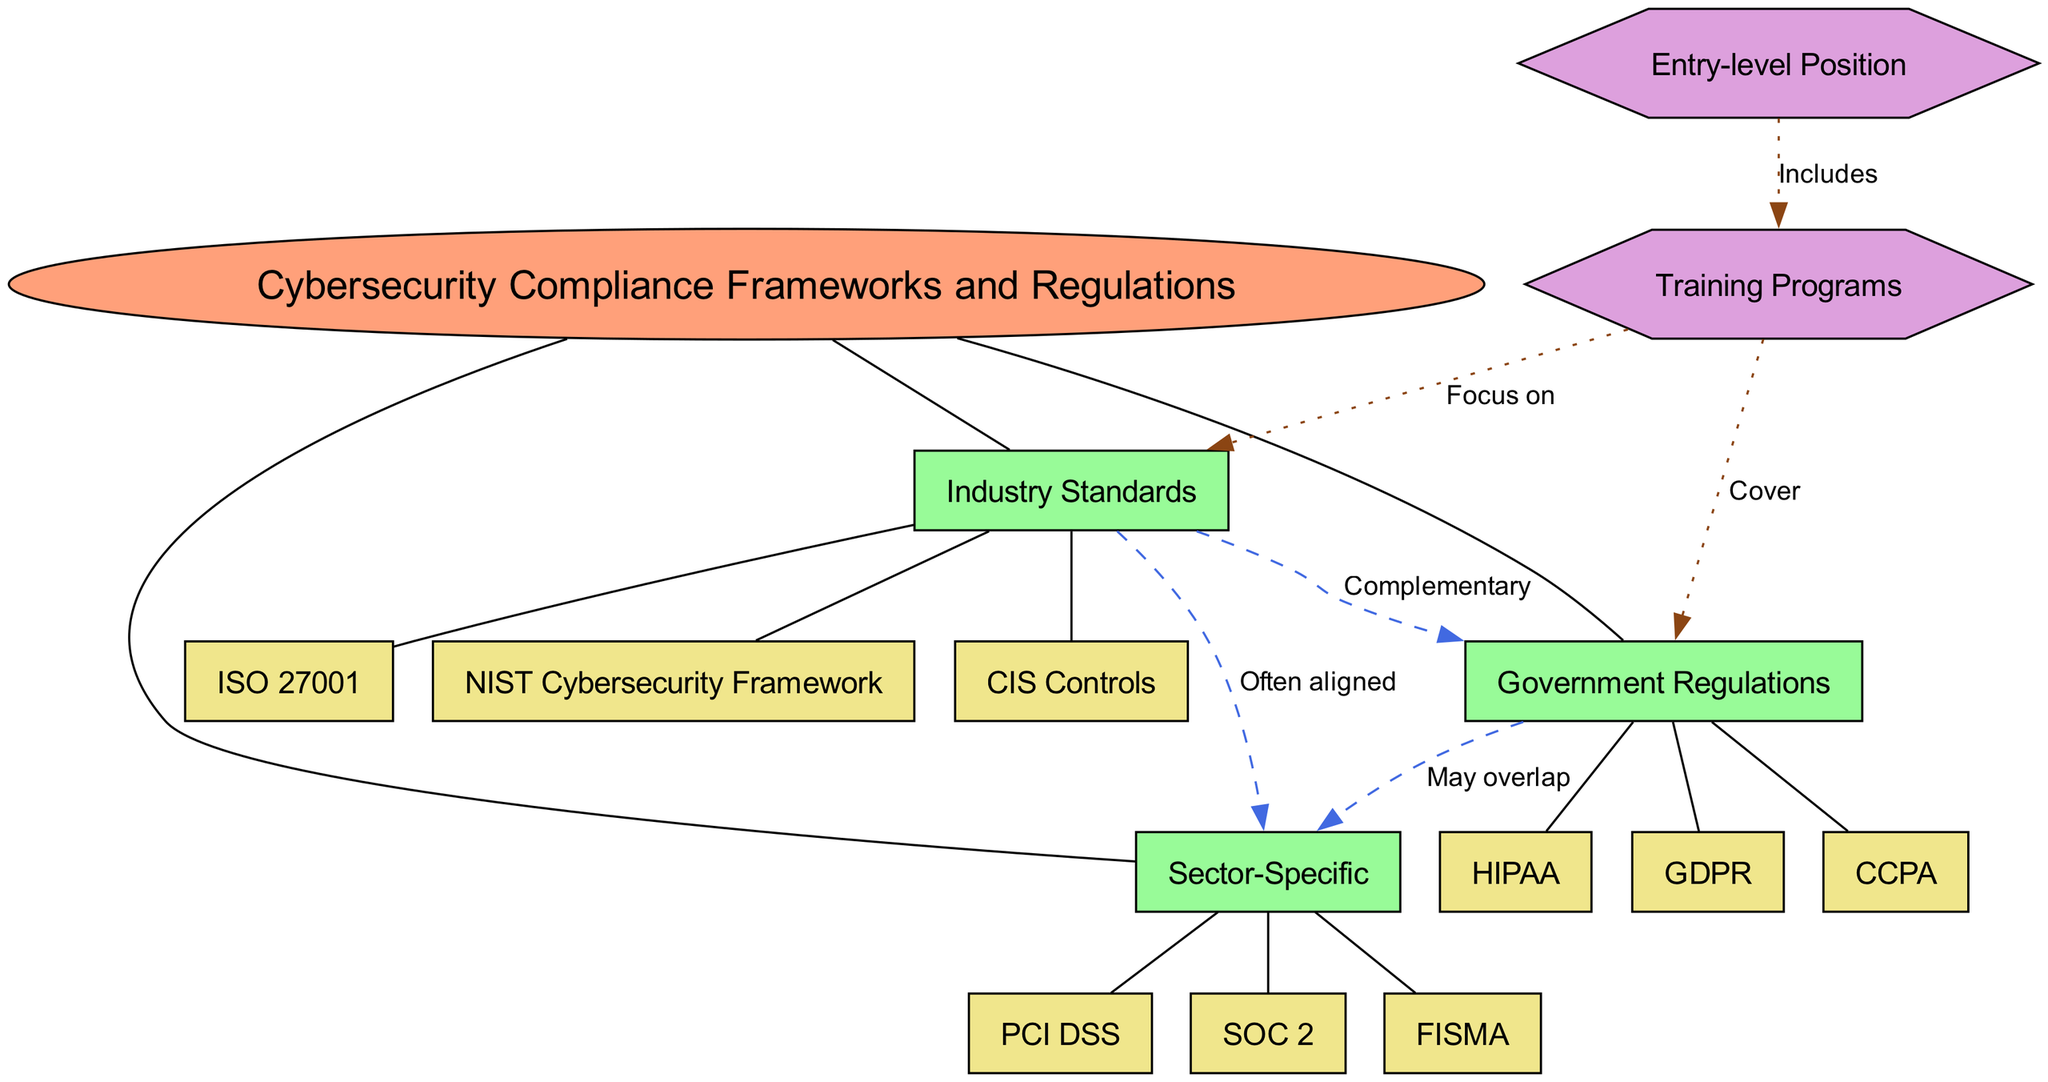What is the central concept of the diagram? The central concept is clearly labeled at the center of the diagram, specifically as "Cybersecurity Compliance Frameworks and Regulations."
Answer: Cybersecurity Compliance Frameworks and Regulations How many main branches are there in the diagram? By counting the labels connected directly to the central concept, we see there are three main branches: Industry Standards, Government Regulations, and Sector-Specific.
Answer: 3 What is an example of an Industry Standard? Under the main branch labeled "Industry Standards," there are three sub-branches, one of which is "ISO 27001."
Answer: ISO 27001 Which Government Regulation may overlap with Sector-Specific regulations? The connection between "Government Regulations" and "Sector-Specific" shows that they "May overlap." This implies that there is a relationship where the GDPR, CCPA, or HIPAA could have overlaps with some Sector-Specific regulations.
Answer: May overlap What connection describes the relationship between Industry Standards and Sector-Specific? The dotted line connecting "Industry Standards" to "Sector-Specific" is labeled "Often aligned," indicating a strong relationship.
Answer: Often aligned Which additional node is connected to Training Programs? The additional node "Entry-level Position" is uniquely connected to "Training Programs," indicating its relevance to that node.
Answer: Entry-level Position What is covered in the Training Programs? The "Training Programs" node has connections indicating that it "Cover" Government Regulations, which suggests its focus on important compliance topics.
Answer: Cover How do Training Programs focus on Industry Standards? The connection is made clear with a label that states Training Programs "Focus on" Industry Standards, indicating the emphasis in that area.
Answer: Focus on What label describes the connection between Government Regulations and Sector-Specific? The label on the edge connecting these two branches is "May overlap," signifying potential intersections between these categories.
Answer: May overlap 